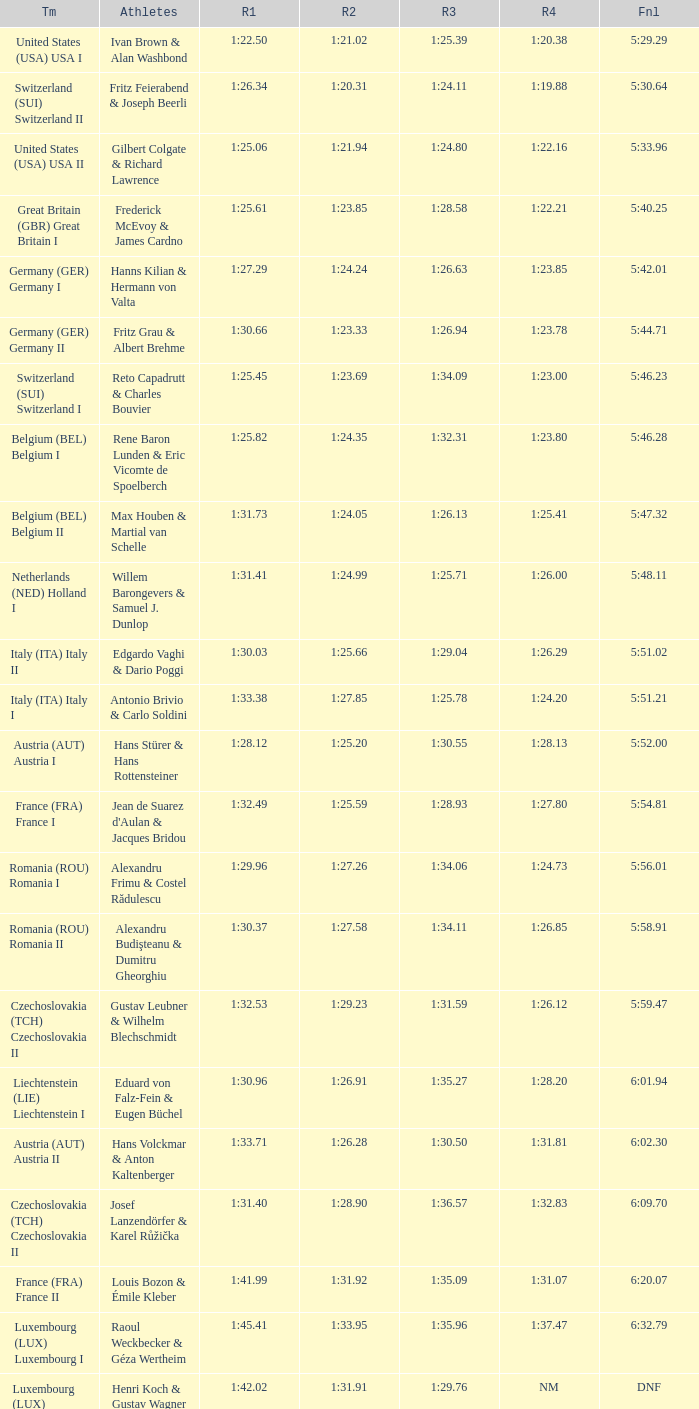Which Final has a Run 2 of 1:27.58? 5:58.91. 